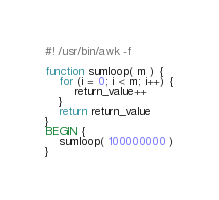Convert code to text. <code><loc_0><loc_0><loc_500><loc_500><_Awk_>#! /usr/bin/awk -f

function sumloop( m ) {
	for (i = 0; i < m; i++) {
		return_value++
	}
	return return_value
}
BEGIN {
	sumloop( 100000000 )
}
</code> 